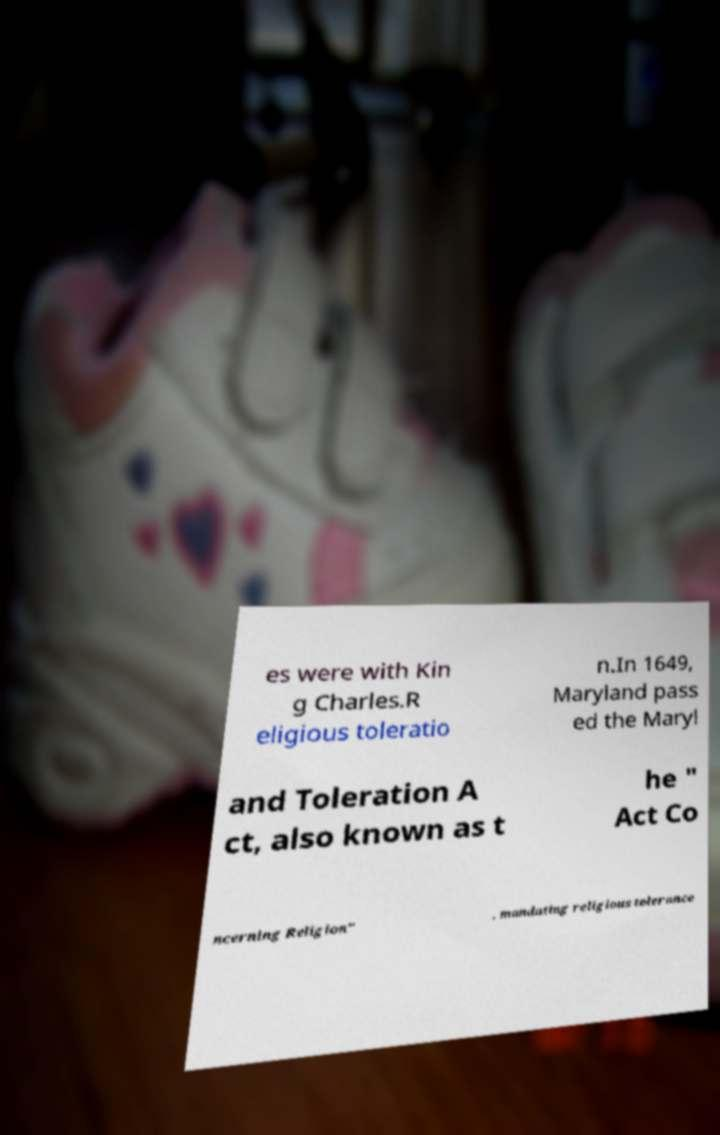Please read and relay the text visible in this image. What does it say? es were with Kin g Charles.R eligious toleratio n.In 1649, Maryland pass ed the Maryl and Toleration A ct, also known as t he " Act Co ncerning Religion" , mandating religious tolerance 